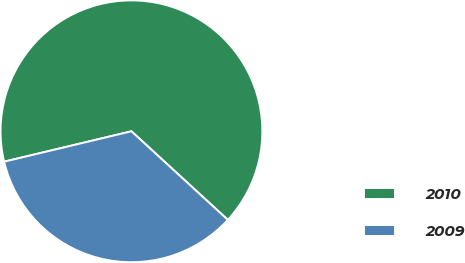Convert chart to OTSL. <chart><loc_0><loc_0><loc_500><loc_500><pie_chart><fcel>2010<fcel>2009<nl><fcel>65.56%<fcel>34.44%<nl></chart> 